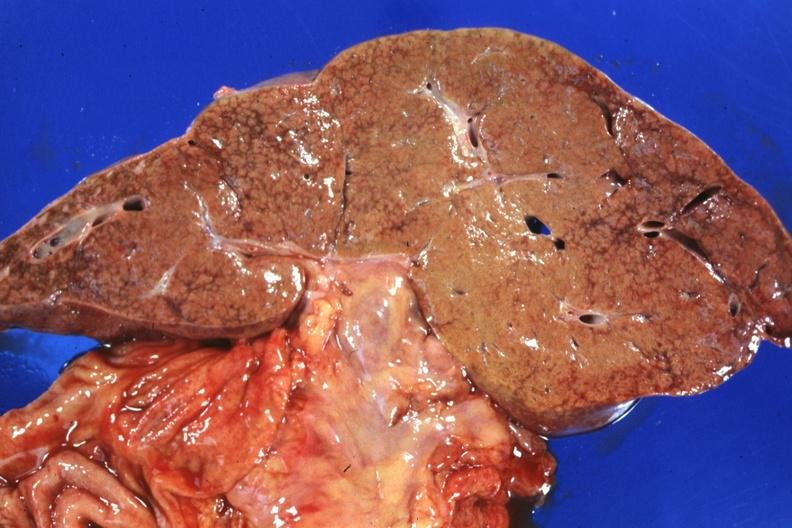s hepatobiliary present?
Answer the question using a single word or phrase. Yes 